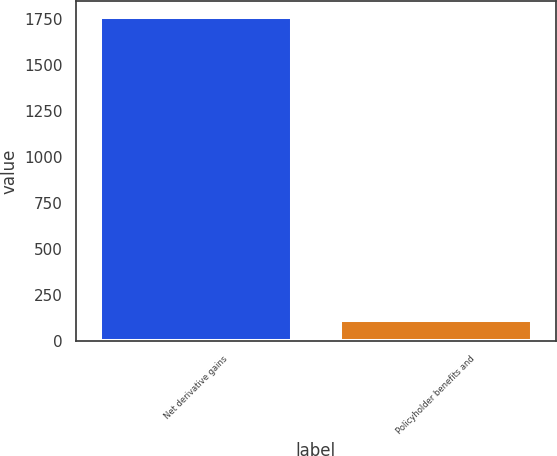<chart> <loc_0><loc_0><loc_500><loc_500><bar_chart><fcel>Net derivative gains<fcel>Policyholder benefits and<nl><fcel>1758<fcel>114<nl></chart> 